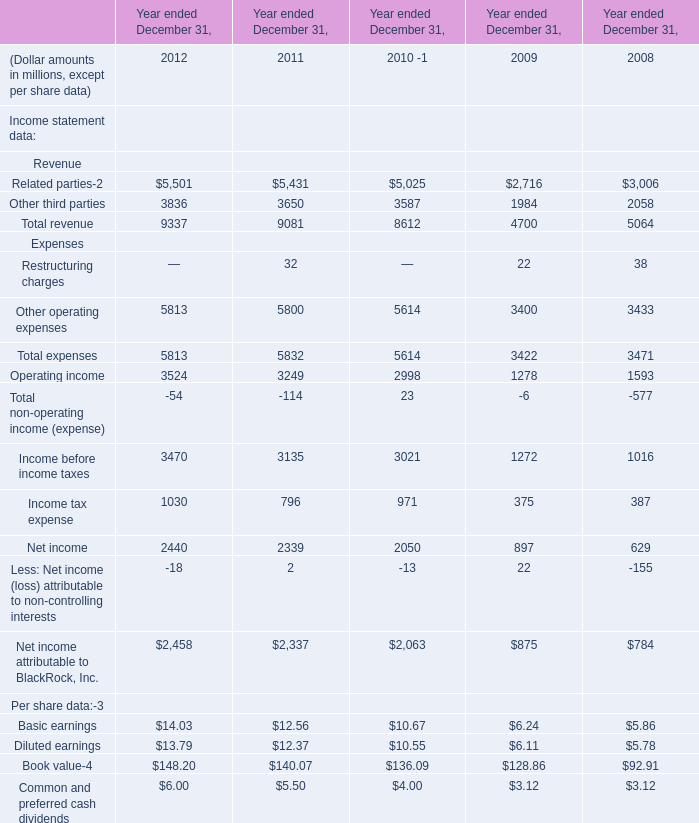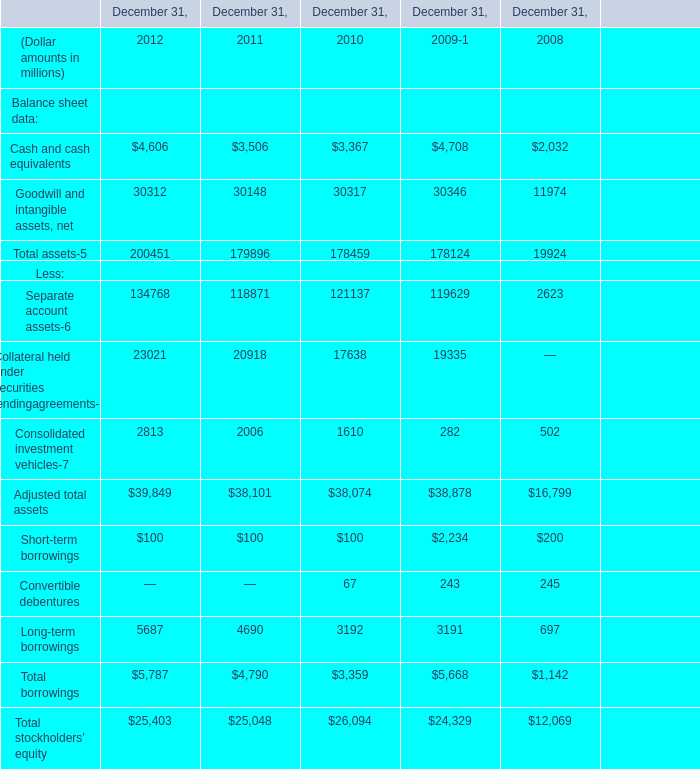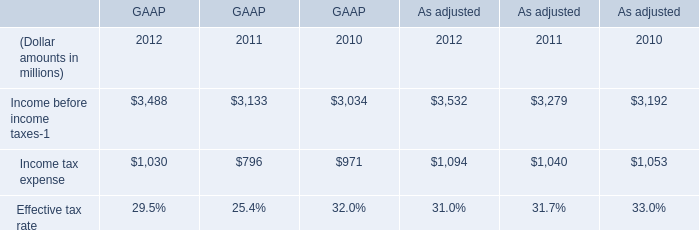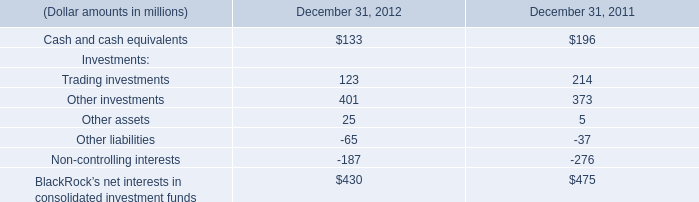What's the sum of Total assets in 2012? (in million) 
Answer: 200451. 